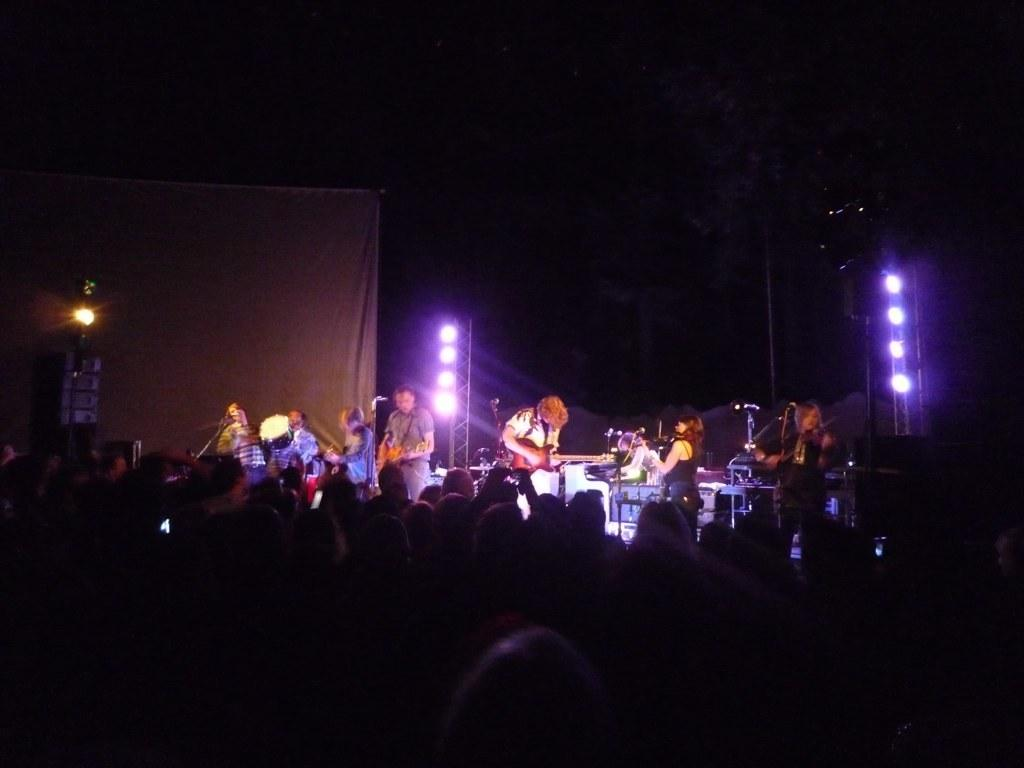What is the overall lighting condition in the image? The image is dark. What are the people in the image doing? The people in the image are playing musical instruments. What equipment is visible in the image that might be used for amplifying sound? Microphones are visible in the image. What type of lighting is present in the image? Lights are present in the image. What type of backdrop can be seen in the image? There is a curtain in the image. Who else is present in the image besides the musicians? There are people in the audience in the image. What flavor of ice cream is being served to the audience in the image? There is no ice cream present in the image; it features people playing musical instruments and an audience. 